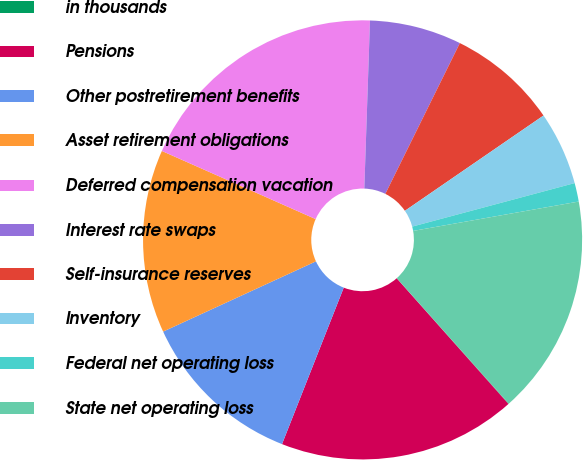<chart> <loc_0><loc_0><loc_500><loc_500><pie_chart><fcel>in thousands<fcel>Pensions<fcel>Other postretirement benefits<fcel>Asset retirement obligations<fcel>Deferred compensation vacation<fcel>Interest rate swaps<fcel>Self-insurance reserves<fcel>Inventory<fcel>Federal net operating loss<fcel>State net operating loss<nl><fcel>0.03%<fcel>17.55%<fcel>12.16%<fcel>13.5%<fcel>18.9%<fcel>6.77%<fcel>8.11%<fcel>5.42%<fcel>1.37%<fcel>16.2%<nl></chart> 